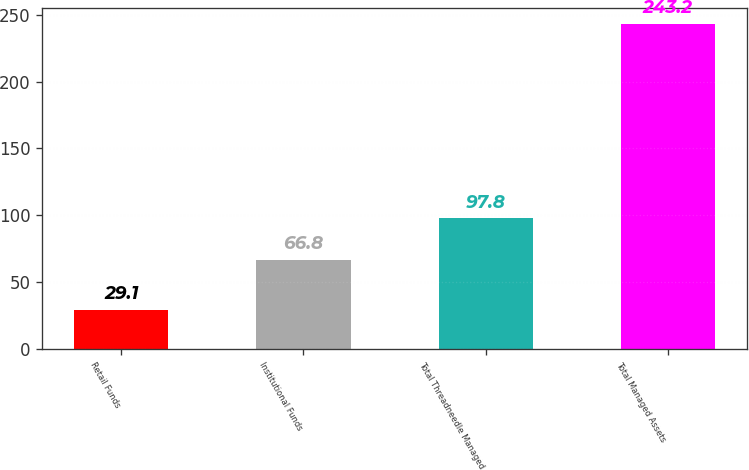Convert chart to OTSL. <chart><loc_0><loc_0><loc_500><loc_500><bar_chart><fcel>Retail Funds<fcel>Institutional Funds<fcel>Total Threadneedle Managed<fcel>Total Managed Assets<nl><fcel>29.1<fcel>66.8<fcel>97.8<fcel>243.2<nl></chart> 